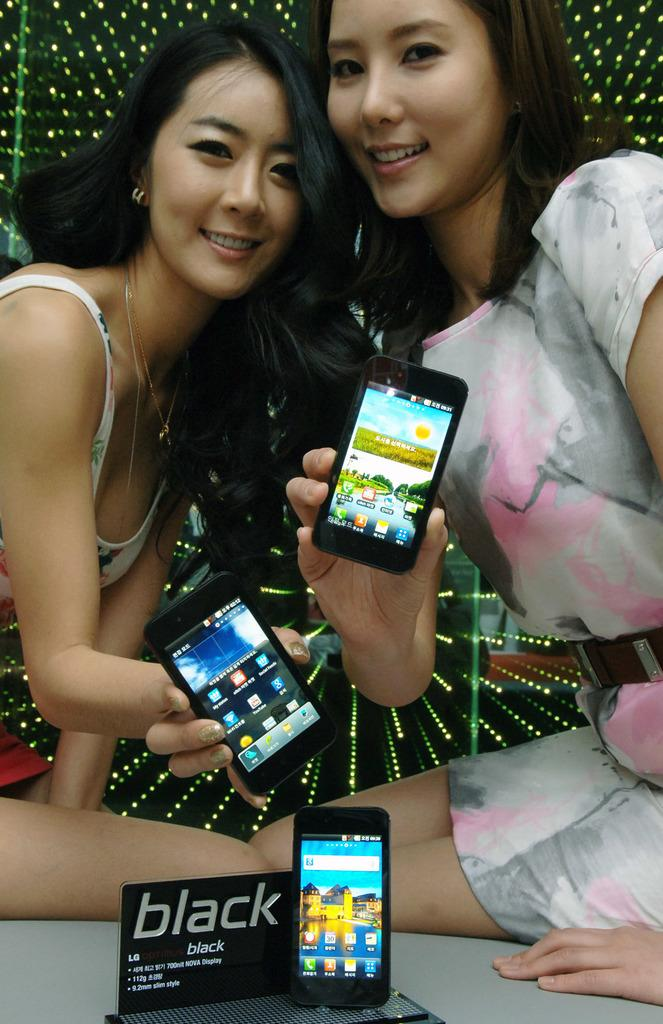<image>
Summarize the visual content of the image. Two young ladies hold up phones near a BLACK display sign. 